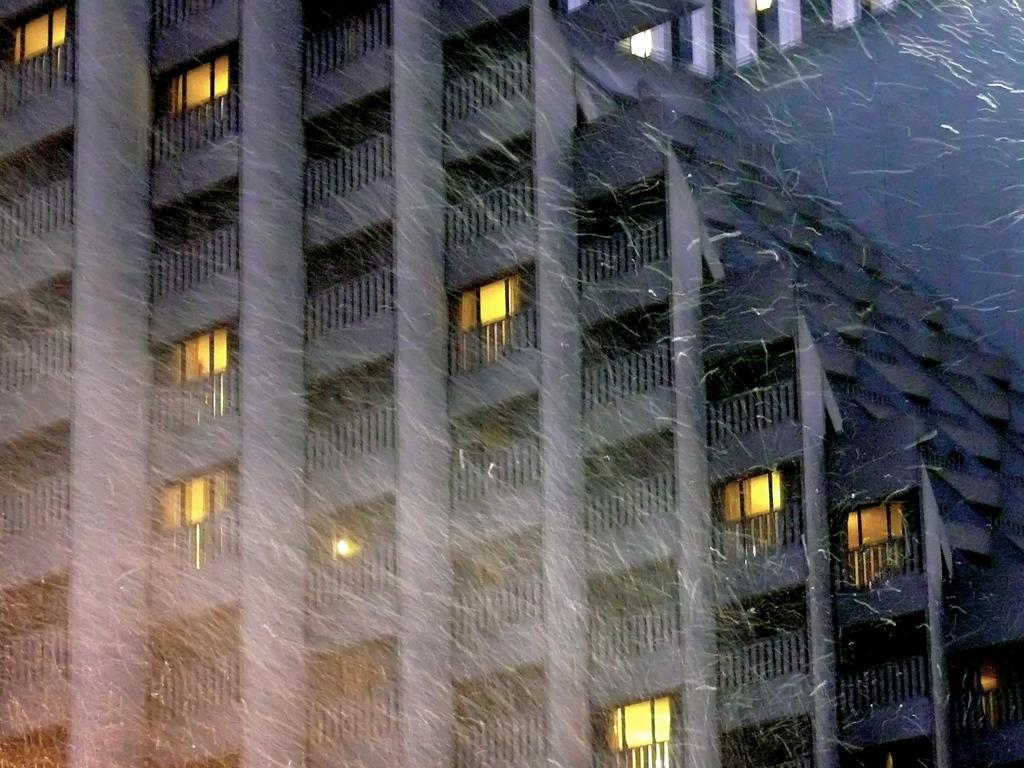Describe this image in one or two sentences. In this image I can see a building along with the windows and there is a snowfall. 